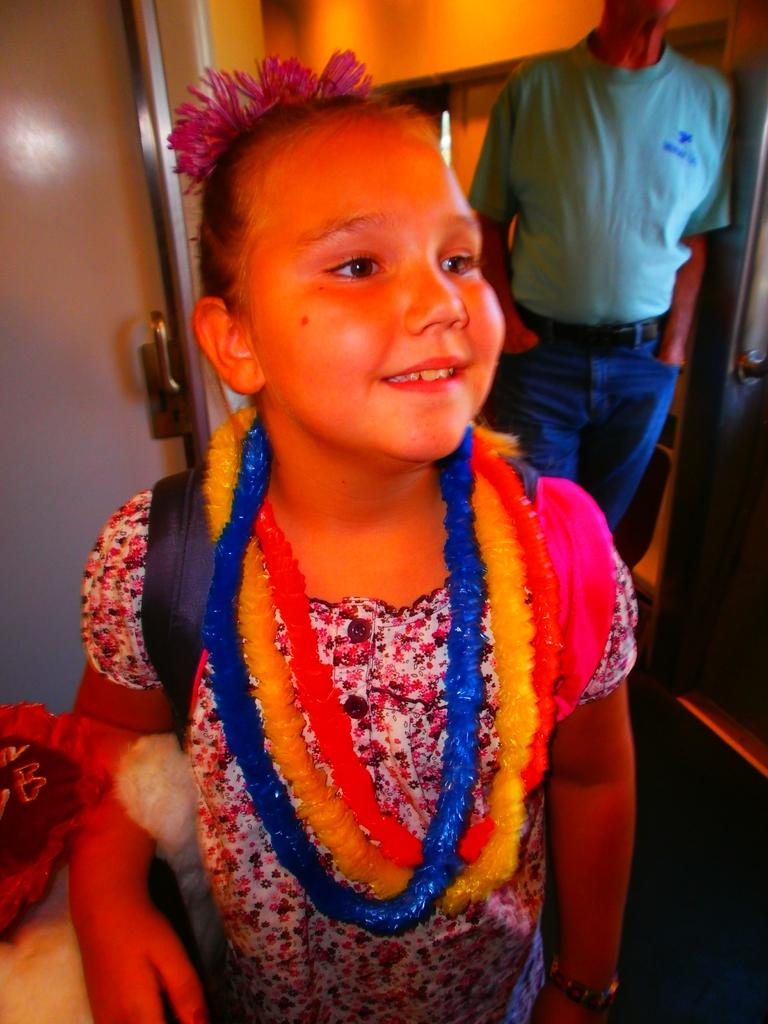What is the main subject of the image? There is a girl standing in the image. What is the girl wearing? The girl is wearing garlands. What can be seen beside the girl? There are objects beside the girl. Who else is present in the image? There is a person standing behind the girl. What type of architectural feature is visible in the image? There is a door and a wall visible in the image. What type of mitten is the girl holding in the image? There is no mitten present in the image. Is the person standing behind the girl an actor in a play? There is no information about the person's occupation or involvement in a play in the image. Can you see a rifle in the image? There is no rifle present in the image. 